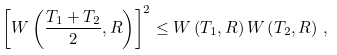Convert formula to latex. <formula><loc_0><loc_0><loc_500><loc_500>\left [ W \left ( \frac { T _ { 1 } + T _ { 2 } } { 2 } , R \right ) \right ] ^ { 2 } \leq W \left ( T _ { 1 } , R \right ) W \left ( T _ { 2 } , R \right ) \, ,</formula> 